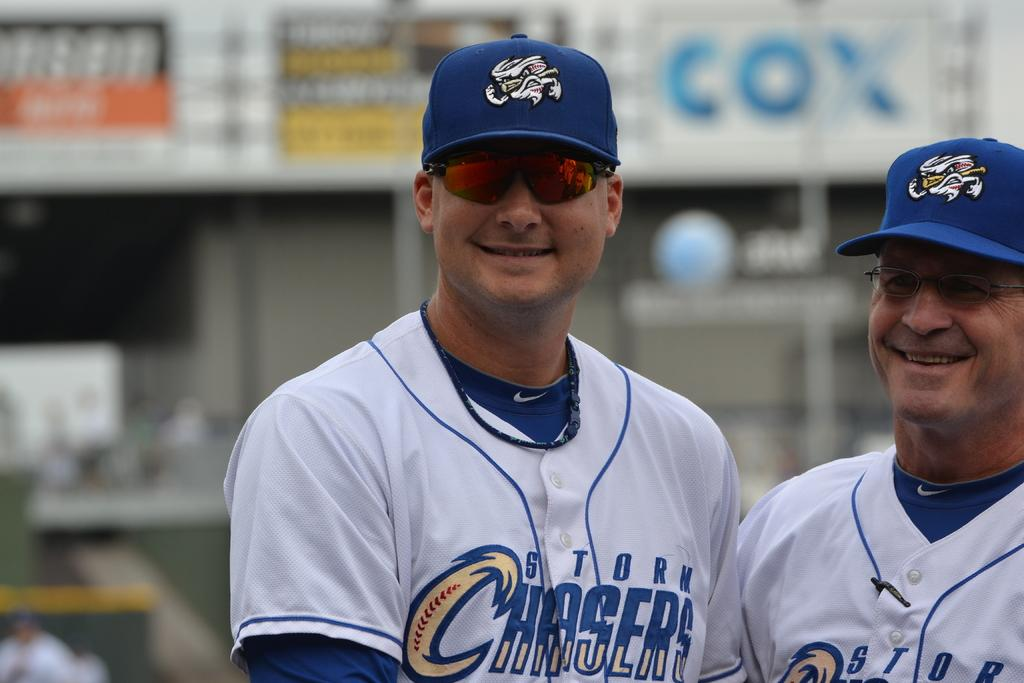<image>
Present a compact description of the photo's key features. Two wear wearing Storm Chasers baseball uniforms stand next to each other. 